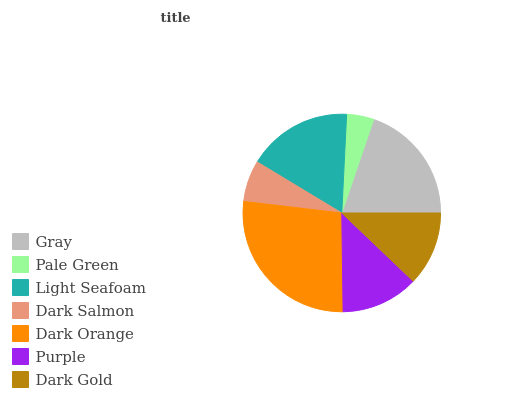Is Pale Green the minimum?
Answer yes or no. Yes. Is Dark Orange the maximum?
Answer yes or no. Yes. Is Light Seafoam the minimum?
Answer yes or no. No. Is Light Seafoam the maximum?
Answer yes or no. No. Is Light Seafoam greater than Pale Green?
Answer yes or no. Yes. Is Pale Green less than Light Seafoam?
Answer yes or no. Yes. Is Pale Green greater than Light Seafoam?
Answer yes or no. No. Is Light Seafoam less than Pale Green?
Answer yes or no. No. Is Purple the high median?
Answer yes or no. Yes. Is Purple the low median?
Answer yes or no. Yes. Is Dark Orange the high median?
Answer yes or no. No. Is Dark Orange the low median?
Answer yes or no. No. 